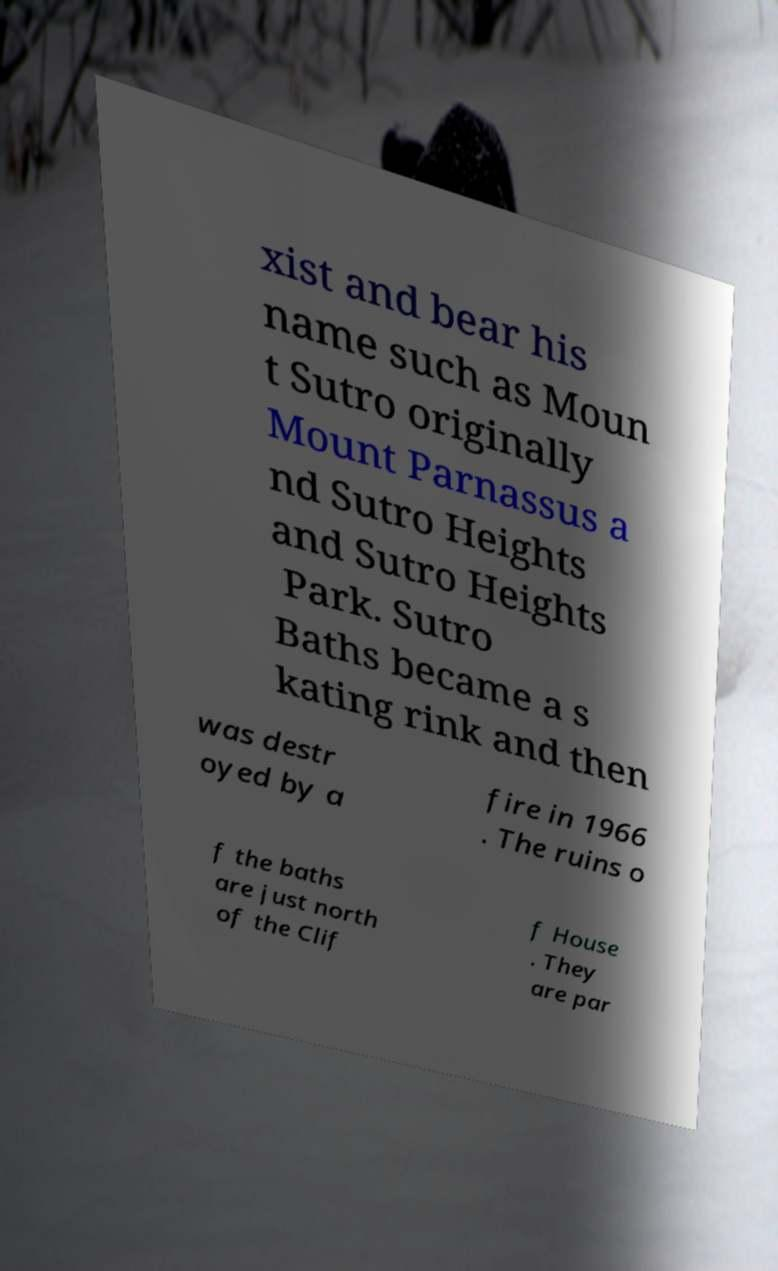Can you accurately transcribe the text from the provided image for me? xist and bear his name such as Moun t Sutro originally Mount Parnassus a nd Sutro Heights and Sutro Heights Park. Sutro Baths became a s kating rink and then was destr oyed by a fire in 1966 . The ruins o f the baths are just north of the Clif f House . They are par 